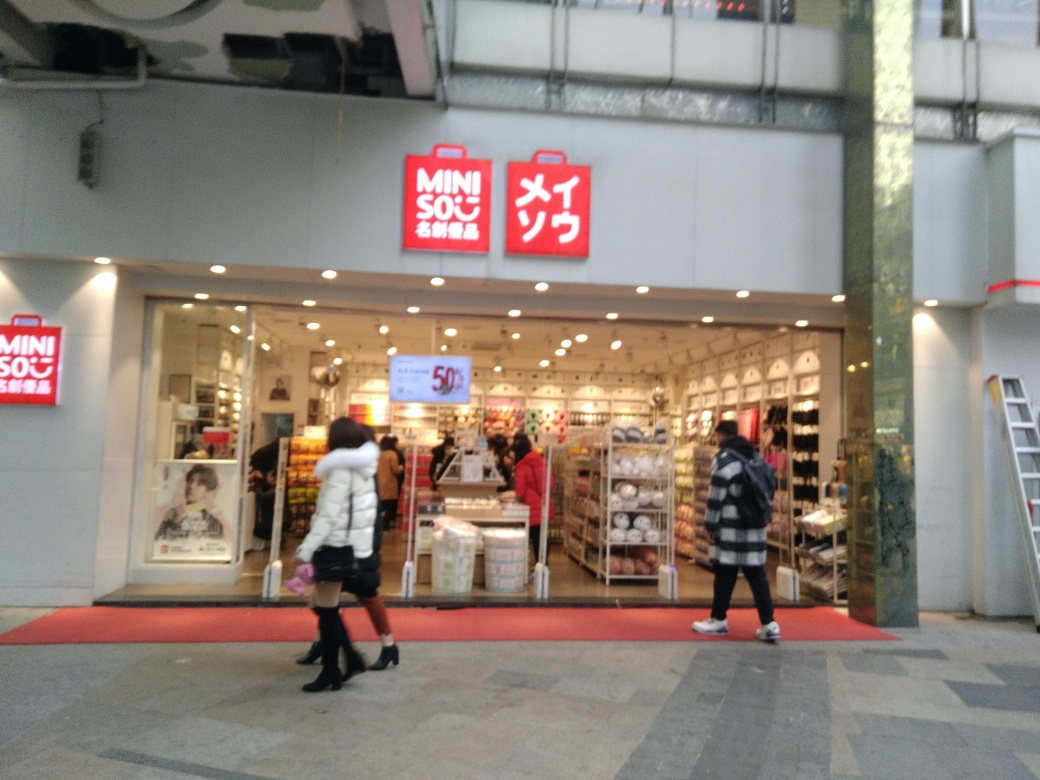Can you determine the type of demographic the store targets based on the visual cues in the image? While it's challenging to ascertain the exact demographic with certainty, the visual cues from the image such as the style of the products, the store layout, and the modern branding suggest that the store is targeting a broad audience that values affordability, practicality, and modern design. The merchandise on display is presented in a way that suggests accessibility and appeal to a wide range of shoppers, potentially including young adults, families, and individuals seeking functional yet stylish home goods. 